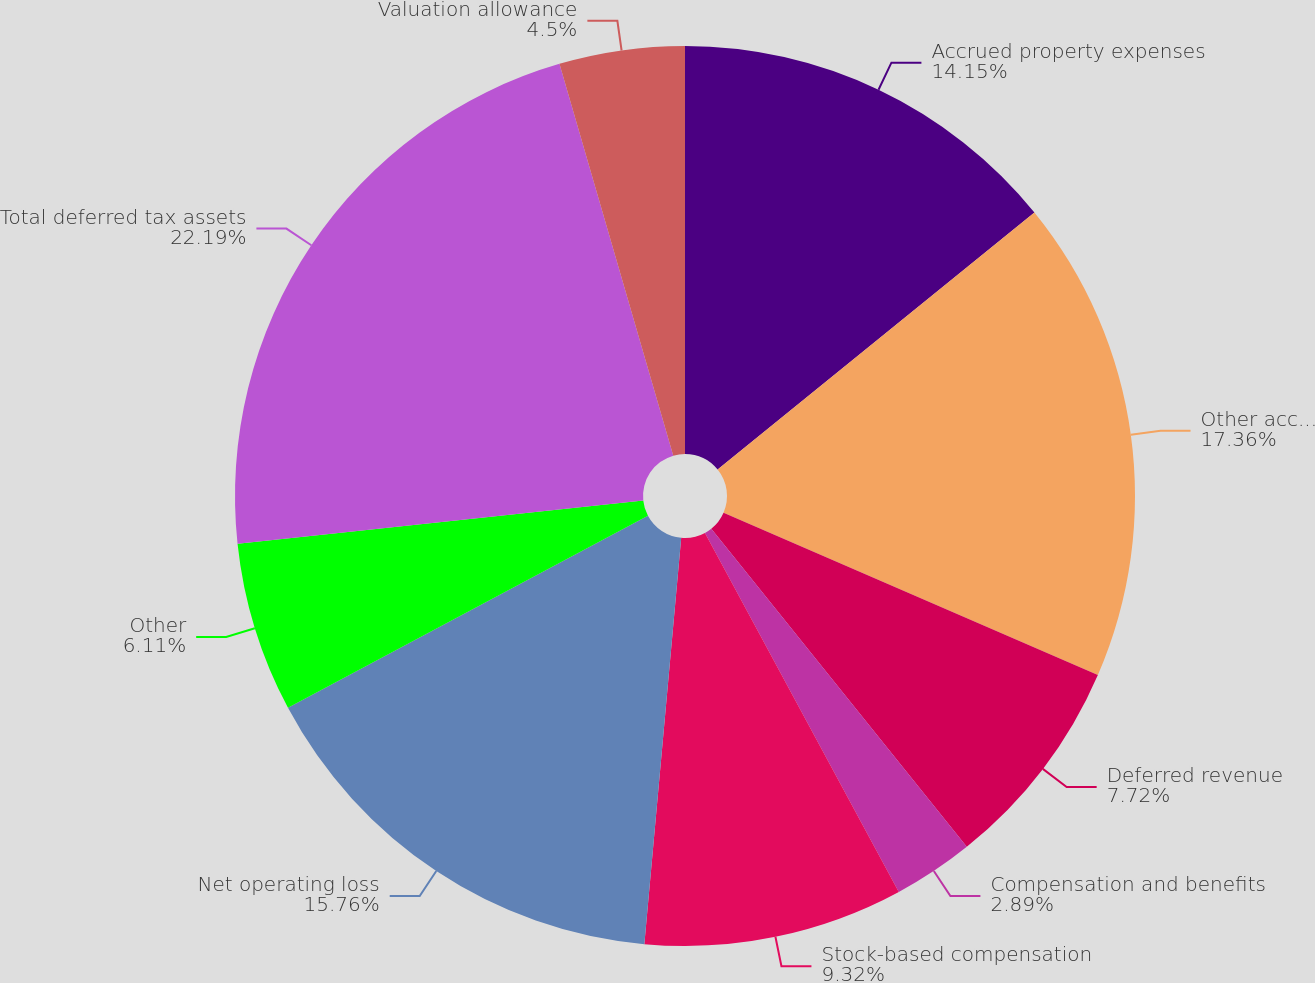Convert chart. <chart><loc_0><loc_0><loc_500><loc_500><pie_chart><fcel>Accrued property expenses<fcel>Other accrued expenses<fcel>Deferred revenue<fcel>Compensation and benefits<fcel>Stock-based compensation<fcel>Net operating loss<fcel>Other<fcel>Total deferred tax assets<fcel>Valuation allowance<nl><fcel>14.15%<fcel>17.36%<fcel>7.72%<fcel>2.89%<fcel>9.32%<fcel>15.76%<fcel>6.11%<fcel>22.19%<fcel>4.5%<nl></chart> 